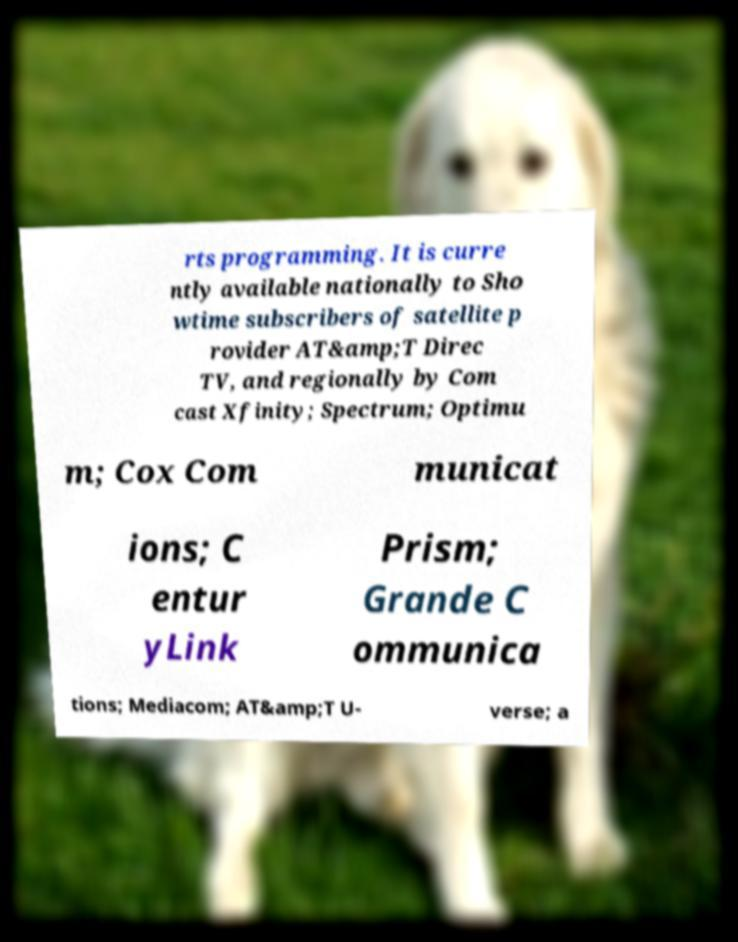Please identify and transcribe the text found in this image. rts programming. It is curre ntly available nationally to Sho wtime subscribers of satellite p rovider AT&amp;T Direc TV, and regionally by Com cast Xfinity; Spectrum; Optimu m; Cox Com municat ions; C entur yLink Prism; Grande C ommunica tions; Mediacom; AT&amp;T U- verse; a 